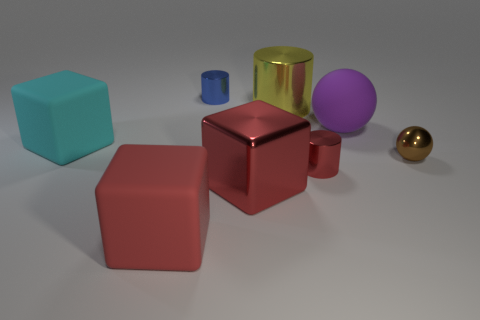What number of other objects are the same color as the big shiny block?
Your answer should be very brief. 2. How many red cubes are the same material as the purple ball?
Make the answer very short. 1. What number of other things are the same size as the red shiny block?
Your response must be concise. 4. Is there a purple thing that has the same size as the blue metallic object?
Offer a very short reply. No. Is the color of the large matte thing in front of the cyan matte block the same as the big metal block?
Offer a terse response. Yes. How many things are large green rubber things or matte blocks?
Offer a very short reply. 2. There is a matte thing behind the cyan cube; does it have the same size as the red cylinder?
Make the answer very short. No. What is the size of the metal cylinder that is on the right side of the metallic cube and behind the tiny metallic sphere?
Give a very brief answer. Large. How many other things are there of the same shape as the large purple rubber object?
Offer a terse response. 1. How many other objects are there of the same material as the big cylinder?
Ensure brevity in your answer.  4. 